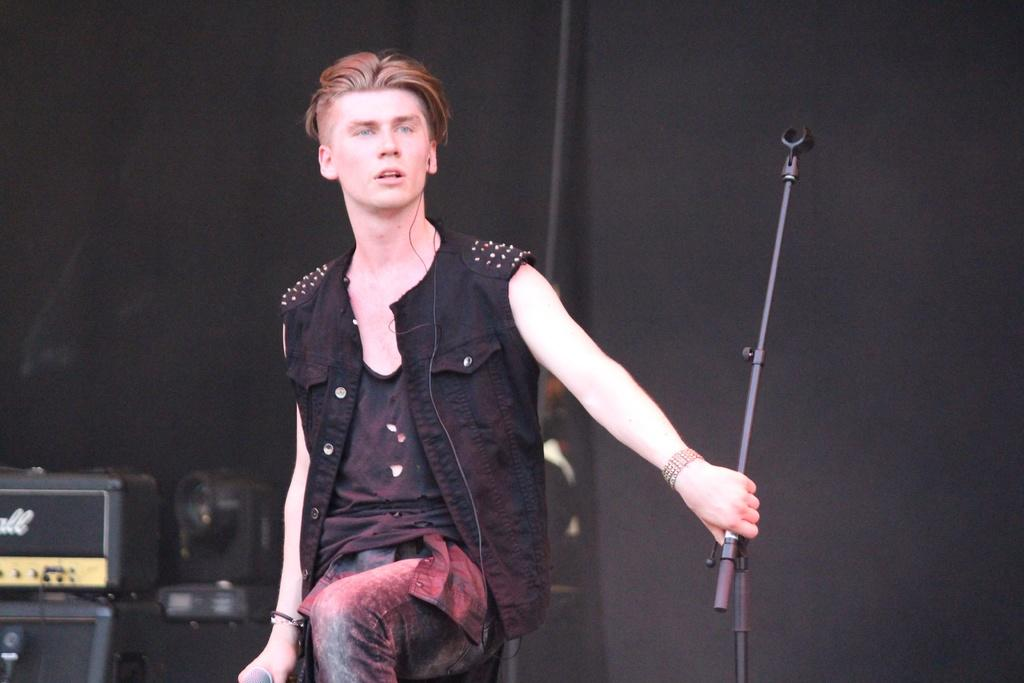What is the man in the image doing? The man is standing in the image and holding a mic stand. What objects are present in the background of the image? There is a light and a speaker in the background of the image. What type of food is the man eating in the image? There is no food present in the image; the man is holding a mic stand. Can you describe the garden in the image? There is no garden present in the image. 